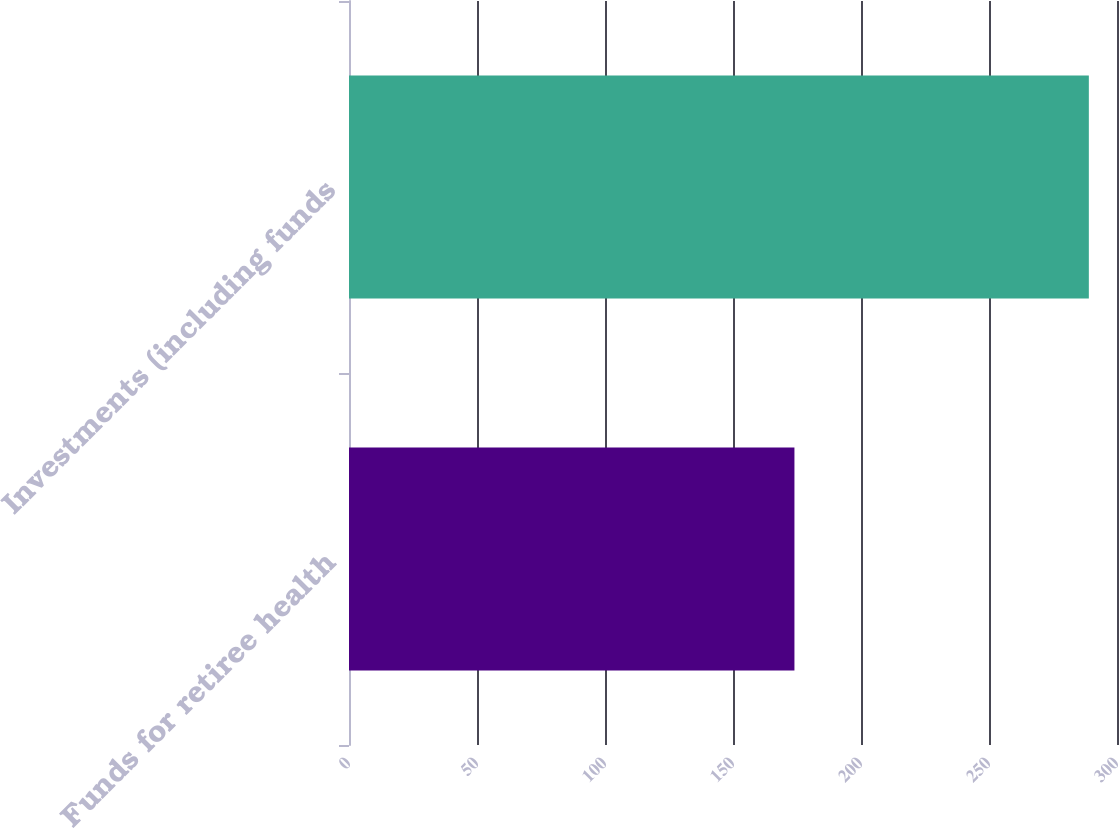Convert chart to OTSL. <chart><loc_0><loc_0><loc_500><loc_500><bar_chart><fcel>Funds for retiree health<fcel>Investments (including funds<nl><fcel>174<fcel>289<nl></chart> 